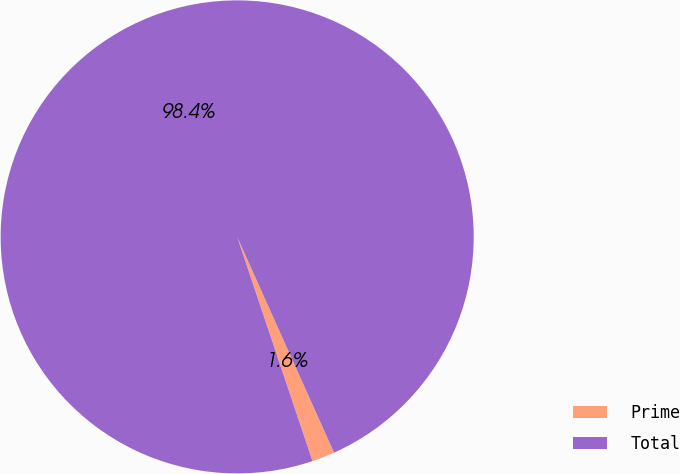<chart> <loc_0><loc_0><loc_500><loc_500><pie_chart><fcel>Prime<fcel>Total<nl><fcel>1.56%<fcel>98.44%<nl></chart> 